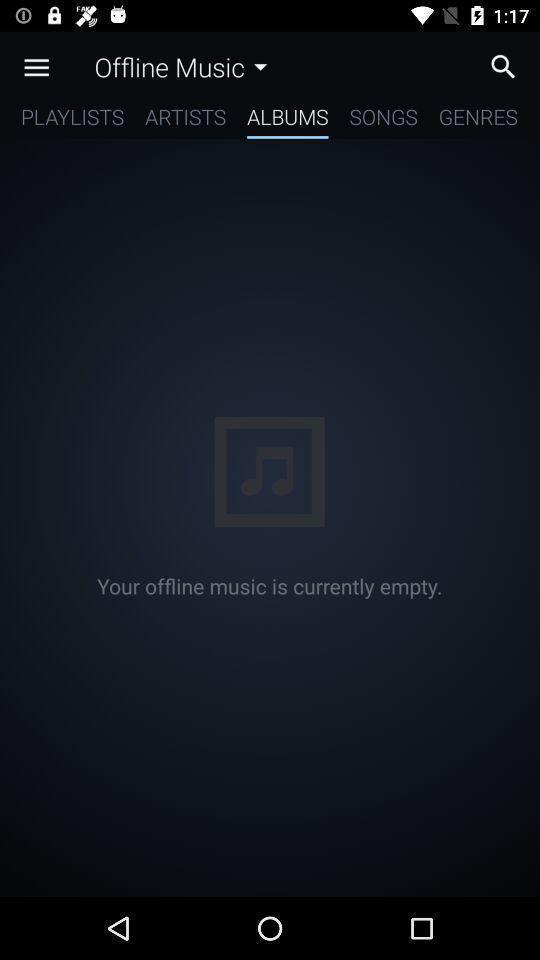Tell me about the visual elements in this screen capture. Page of a music player app with empty list. 